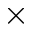<formula> <loc_0><loc_0><loc_500><loc_500>\times</formula> 